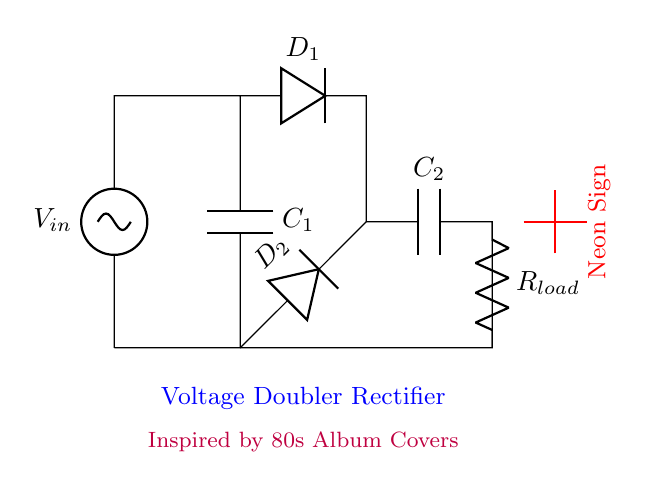What is the input voltage of the circuit? The circuit diagram labels the input voltage as V_in, indicating that it is the voltage source connected to the circuit.
Answer: V_in What type of rectifier is this circuit? The diagram labels the circuit explicitly as a voltage doubler rectifier, which indicates that it converts AC voltage to DC and doubles the voltage.
Answer: Voltage doubler rectifier How many capacitors are present in the circuit? By closely observing the circuit diagram, two capacitors are identified: C_1 and C_2.
Answer: 2 What is the purpose of the diodes in this circuit? The diodes D_1 and D_2 work to allow current to flow in one direction only, thus converting alternating current (AC) to direct current (DC).
Answer: Convert AC to DC What is the load connected in this circuit? The diagram shows a resistor labeled R_load, which indicates that it serves as the load connected to the output of the voltage doubler rectifier circuit.
Answer: R_load What does the label "Neon Sign" indicate? The red label in the circuit indicates that the output of this circuit is designed to power a neon sign, a key component of the overall project inspired by 80s album covers.
Answer: Neon sign What happens if you increase the input voltage? Increasing the input voltage, V_in, will proportionally increase the output voltage at the load, as the rectifier is designed to double the input voltage.
Answer: Increase output voltage 